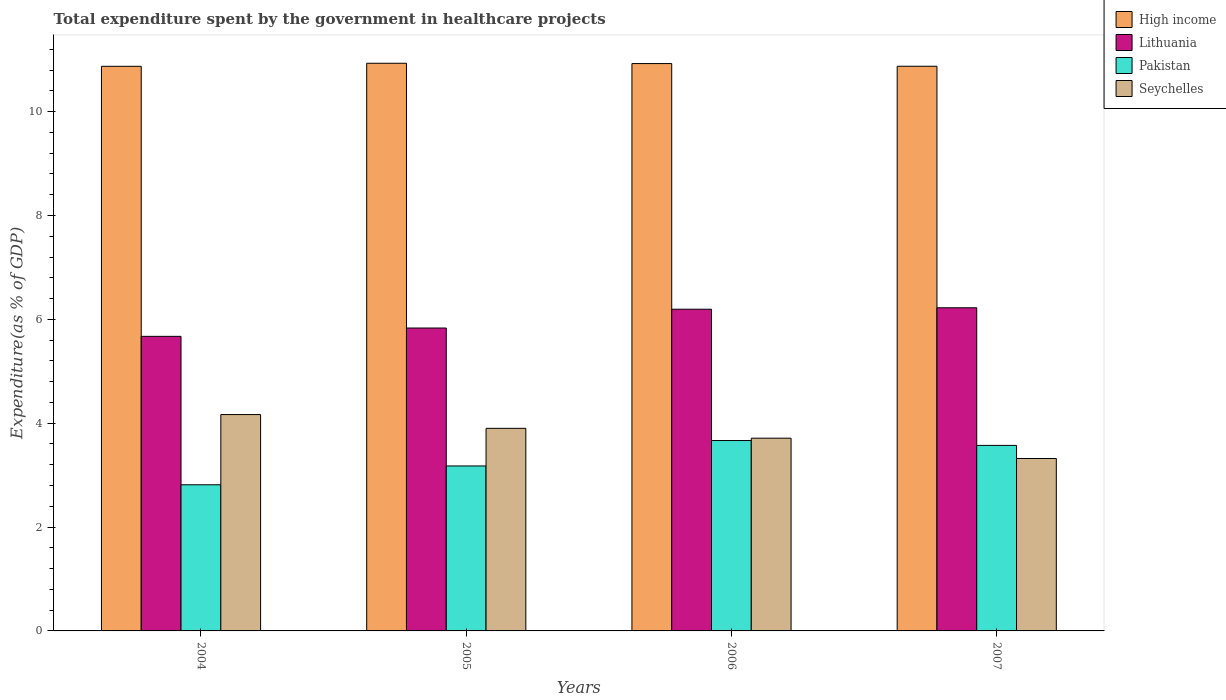How many different coloured bars are there?
Provide a short and direct response. 4. How many groups of bars are there?
Make the answer very short. 4. What is the label of the 4th group of bars from the left?
Ensure brevity in your answer.  2007. In how many cases, is the number of bars for a given year not equal to the number of legend labels?
Your answer should be compact. 0. What is the total expenditure spent by the government in healthcare projects in High income in 2005?
Your answer should be very brief. 10.93. Across all years, what is the maximum total expenditure spent by the government in healthcare projects in Pakistan?
Your response must be concise. 3.67. Across all years, what is the minimum total expenditure spent by the government in healthcare projects in High income?
Offer a terse response. 10.87. In which year was the total expenditure spent by the government in healthcare projects in Seychelles minimum?
Provide a short and direct response. 2007. What is the total total expenditure spent by the government in healthcare projects in Pakistan in the graph?
Keep it short and to the point. 13.23. What is the difference between the total expenditure spent by the government in healthcare projects in High income in 2004 and that in 2006?
Provide a short and direct response. -0.05. What is the difference between the total expenditure spent by the government in healthcare projects in Pakistan in 2007 and the total expenditure spent by the government in healthcare projects in Lithuania in 2004?
Offer a very short reply. -2.1. What is the average total expenditure spent by the government in healthcare projects in Seychelles per year?
Your response must be concise. 3.77. In the year 2004, what is the difference between the total expenditure spent by the government in healthcare projects in High income and total expenditure spent by the government in healthcare projects in Pakistan?
Ensure brevity in your answer.  8.06. What is the ratio of the total expenditure spent by the government in healthcare projects in High income in 2004 to that in 2006?
Provide a short and direct response. 1. Is the difference between the total expenditure spent by the government in healthcare projects in High income in 2005 and 2007 greater than the difference between the total expenditure spent by the government in healthcare projects in Pakistan in 2005 and 2007?
Provide a short and direct response. Yes. What is the difference between the highest and the second highest total expenditure spent by the government in healthcare projects in High income?
Give a very brief answer. 0.01. What is the difference between the highest and the lowest total expenditure spent by the government in healthcare projects in Pakistan?
Your response must be concise. 0.85. What does the 4th bar from the left in 2006 represents?
Offer a very short reply. Seychelles. What does the 4th bar from the right in 2004 represents?
Provide a succinct answer. High income. How many bars are there?
Offer a terse response. 16. How many years are there in the graph?
Provide a short and direct response. 4. What is the difference between two consecutive major ticks on the Y-axis?
Your response must be concise. 2. Are the values on the major ticks of Y-axis written in scientific E-notation?
Offer a terse response. No. Does the graph contain grids?
Your answer should be compact. No. Where does the legend appear in the graph?
Make the answer very short. Top right. How are the legend labels stacked?
Your answer should be compact. Vertical. What is the title of the graph?
Provide a succinct answer. Total expenditure spent by the government in healthcare projects. Does "Fragile and conflict affected situations" appear as one of the legend labels in the graph?
Your answer should be very brief. No. What is the label or title of the Y-axis?
Your answer should be very brief. Expenditure(as % of GDP). What is the Expenditure(as % of GDP) of High income in 2004?
Keep it short and to the point. 10.87. What is the Expenditure(as % of GDP) of Lithuania in 2004?
Offer a terse response. 5.67. What is the Expenditure(as % of GDP) in Pakistan in 2004?
Provide a succinct answer. 2.81. What is the Expenditure(as % of GDP) in Seychelles in 2004?
Give a very brief answer. 4.17. What is the Expenditure(as % of GDP) of High income in 2005?
Your response must be concise. 10.93. What is the Expenditure(as % of GDP) in Lithuania in 2005?
Offer a very short reply. 5.83. What is the Expenditure(as % of GDP) in Pakistan in 2005?
Offer a terse response. 3.18. What is the Expenditure(as % of GDP) in Seychelles in 2005?
Your response must be concise. 3.9. What is the Expenditure(as % of GDP) in High income in 2006?
Provide a short and direct response. 10.93. What is the Expenditure(as % of GDP) in Lithuania in 2006?
Keep it short and to the point. 6.2. What is the Expenditure(as % of GDP) in Pakistan in 2006?
Your answer should be very brief. 3.67. What is the Expenditure(as % of GDP) in Seychelles in 2006?
Make the answer very short. 3.71. What is the Expenditure(as % of GDP) in High income in 2007?
Your answer should be very brief. 10.87. What is the Expenditure(as % of GDP) of Lithuania in 2007?
Provide a succinct answer. 6.22. What is the Expenditure(as % of GDP) of Pakistan in 2007?
Keep it short and to the point. 3.57. What is the Expenditure(as % of GDP) in Seychelles in 2007?
Provide a succinct answer. 3.32. Across all years, what is the maximum Expenditure(as % of GDP) of High income?
Your answer should be compact. 10.93. Across all years, what is the maximum Expenditure(as % of GDP) in Lithuania?
Offer a very short reply. 6.22. Across all years, what is the maximum Expenditure(as % of GDP) of Pakistan?
Offer a terse response. 3.67. Across all years, what is the maximum Expenditure(as % of GDP) in Seychelles?
Ensure brevity in your answer.  4.17. Across all years, what is the minimum Expenditure(as % of GDP) of High income?
Keep it short and to the point. 10.87. Across all years, what is the minimum Expenditure(as % of GDP) of Lithuania?
Your response must be concise. 5.67. Across all years, what is the minimum Expenditure(as % of GDP) in Pakistan?
Keep it short and to the point. 2.81. Across all years, what is the minimum Expenditure(as % of GDP) in Seychelles?
Ensure brevity in your answer.  3.32. What is the total Expenditure(as % of GDP) in High income in the graph?
Keep it short and to the point. 43.61. What is the total Expenditure(as % of GDP) in Lithuania in the graph?
Offer a very short reply. 23.92. What is the total Expenditure(as % of GDP) of Pakistan in the graph?
Offer a terse response. 13.23. What is the total Expenditure(as % of GDP) of Seychelles in the graph?
Provide a short and direct response. 15.1. What is the difference between the Expenditure(as % of GDP) in High income in 2004 and that in 2005?
Give a very brief answer. -0.06. What is the difference between the Expenditure(as % of GDP) in Lithuania in 2004 and that in 2005?
Your response must be concise. -0.16. What is the difference between the Expenditure(as % of GDP) in Pakistan in 2004 and that in 2005?
Your response must be concise. -0.36. What is the difference between the Expenditure(as % of GDP) of Seychelles in 2004 and that in 2005?
Your answer should be very brief. 0.27. What is the difference between the Expenditure(as % of GDP) in High income in 2004 and that in 2006?
Keep it short and to the point. -0.05. What is the difference between the Expenditure(as % of GDP) of Lithuania in 2004 and that in 2006?
Make the answer very short. -0.52. What is the difference between the Expenditure(as % of GDP) in Pakistan in 2004 and that in 2006?
Keep it short and to the point. -0.85. What is the difference between the Expenditure(as % of GDP) in Seychelles in 2004 and that in 2006?
Your answer should be very brief. 0.45. What is the difference between the Expenditure(as % of GDP) in High income in 2004 and that in 2007?
Keep it short and to the point. -0. What is the difference between the Expenditure(as % of GDP) of Lithuania in 2004 and that in 2007?
Provide a short and direct response. -0.55. What is the difference between the Expenditure(as % of GDP) in Pakistan in 2004 and that in 2007?
Your answer should be very brief. -0.76. What is the difference between the Expenditure(as % of GDP) in Seychelles in 2004 and that in 2007?
Make the answer very short. 0.85. What is the difference between the Expenditure(as % of GDP) in High income in 2005 and that in 2006?
Keep it short and to the point. 0.01. What is the difference between the Expenditure(as % of GDP) of Lithuania in 2005 and that in 2006?
Your response must be concise. -0.36. What is the difference between the Expenditure(as % of GDP) in Pakistan in 2005 and that in 2006?
Your answer should be very brief. -0.49. What is the difference between the Expenditure(as % of GDP) of Seychelles in 2005 and that in 2006?
Your answer should be compact. 0.19. What is the difference between the Expenditure(as % of GDP) of High income in 2005 and that in 2007?
Keep it short and to the point. 0.06. What is the difference between the Expenditure(as % of GDP) of Lithuania in 2005 and that in 2007?
Make the answer very short. -0.39. What is the difference between the Expenditure(as % of GDP) of Pakistan in 2005 and that in 2007?
Your answer should be compact. -0.4. What is the difference between the Expenditure(as % of GDP) of Seychelles in 2005 and that in 2007?
Your answer should be compact. 0.58. What is the difference between the Expenditure(as % of GDP) of High income in 2006 and that in 2007?
Offer a terse response. 0.05. What is the difference between the Expenditure(as % of GDP) of Lithuania in 2006 and that in 2007?
Offer a very short reply. -0.03. What is the difference between the Expenditure(as % of GDP) of Pakistan in 2006 and that in 2007?
Your answer should be very brief. 0.09. What is the difference between the Expenditure(as % of GDP) of Seychelles in 2006 and that in 2007?
Offer a very short reply. 0.39. What is the difference between the Expenditure(as % of GDP) in High income in 2004 and the Expenditure(as % of GDP) in Lithuania in 2005?
Make the answer very short. 5.04. What is the difference between the Expenditure(as % of GDP) in High income in 2004 and the Expenditure(as % of GDP) in Pakistan in 2005?
Provide a short and direct response. 7.7. What is the difference between the Expenditure(as % of GDP) in High income in 2004 and the Expenditure(as % of GDP) in Seychelles in 2005?
Your answer should be very brief. 6.97. What is the difference between the Expenditure(as % of GDP) of Lithuania in 2004 and the Expenditure(as % of GDP) of Pakistan in 2005?
Give a very brief answer. 2.5. What is the difference between the Expenditure(as % of GDP) in Lithuania in 2004 and the Expenditure(as % of GDP) in Seychelles in 2005?
Make the answer very short. 1.77. What is the difference between the Expenditure(as % of GDP) in Pakistan in 2004 and the Expenditure(as % of GDP) in Seychelles in 2005?
Your answer should be very brief. -1.09. What is the difference between the Expenditure(as % of GDP) in High income in 2004 and the Expenditure(as % of GDP) in Lithuania in 2006?
Keep it short and to the point. 4.68. What is the difference between the Expenditure(as % of GDP) in High income in 2004 and the Expenditure(as % of GDP) in Pakistan in 2006?
Make the answer very short. 7.21. What is the difference between the Expenditure(as % of GDP) of High income in 2004 and the Expenditure(as % of GDP) of Seychelles in 2006?
Your answer should be compact. 7.16. What is the difference between the Expenditure(as % of GDP) in Lithuania in 2004 and the Expenditure(as % of GDP) in Pakistan in 2006?
Offer a terse response. 2.01. What is the difference between the Expenditure(as % of GDP) in Lithuania in 2004 and the Expenditure(as % of GDP) in Seychelles in 2006?
Offer a terse response. 1.96. What is the difference between the Expenditure(as % of GDP) in Pakistan in 2004 and the Expenditure(as % of GDP) in Seychelles in 2006?
Make the answer very short. -0.9. What is the difference between the Expenditure(as % of GDP) in High income in 2004 and the Expenditure(as % of GDP) in Lithuania in 2007?
Provide a succinct answer. 4.65. What is the difference between the Expenditure(as % of GDP) of High income in 2004 and the Expenditure(as % of GDP) of Pakistan in 2007?
Keep it short and to the point. 7.3. What is the difference between the Expenditure(as % of GDP) of High income in 2004 and the Expenditure(as % of GDP) of Seychelles in 2007?
Provide a short and direct response. 7.55. What is the difference between the Expenditure(as % of GDP) in Lithuania in 2004 and the Expenditure(as % of GDP) in Pakistan in 2007?
Ensure brevity in your answer.  2.1. What is the difference between the Expenditure(as % of GDP) of Lithuania in 2004 and the Expenditure(as % of GDP) of Seychelles in 2007?
Keep it short and to the point. 2.35. What is the difference between the Expenditure(as % of GDP) in Pakistan in 2004 and the Expenditure(as % of GDP) in Seychelles in 2007?
Make the answer very short. -0.51. What is the difference between the Expenditure(as % of GDP) of High income in 2005 and the Expenditure(as % of GDP) of Lithuania in 2006?
Your answer should be compact. 4.74. What is the difference between the Expenditure(as % of GDP) in High income in 2005 and the Expenditure(as % of GDP) in Pakistan in 2006?
Provide a short and direct response. 7.27. What is the difference between the Expenditure(as % of GDP) in High income in 2005 and the Expenditure(as % of GDP) in Seychelles in 2006?
Your response must be concise. 7.22. What is the difference between the Expenditure(as % of GDP) in Lithuania in 2005 and the Expenditure(as % of GDP) in Pakistan in 2006?
Your answer should be compact. 2.17. What is the difference between the Expenditure(as % of GDP) of Lithuania in 2005 and the Expenditure(as % of GDP) of Seychelles in 2006?
Your answer should be very brief. 2.12. What is the difference between the Expenditure(as % of GDP) in Pakistan in 2005 and the Expenditure(as % of GDP) in Seychelles in 2006?
Your answer should be compact. -0.53. What is the difference between the Expenditure(as % of GDP) of High income in 2005 and the Expenditure(as % of GDP) of Lithuania in 2007?
Provide a short and direct response. 4.71. What is the difference between the Expenditure(as % of GDP) of High income in 2005 and the Expenditure(as % of GDP) of Pakistan in 2007?
Provide a succinct answer. 7.36. What is the difference between the Expenditure(as % of GDP) in High income in 2005 and the Expenditure(as % of GDP) in Seychelles in 2007?
Provide a short and direct response. 7.61. What is the difference between the Expenditure(as % of GDP) of Lithuania in 2005 and the Expenditure(as % of GDP) of Pakistan in 2007?
Make the answer very short. 2.26. What is the difference between the Expenditure(as % of GDP) of Lithuania in 2005 and the Expenditure(as % of GDP) of Seychelles in 2007?
Your answer should be compact. 2.51. What is the difference between the Expenditure(as % of GDP) of Pakistan in 2005 and the Expenditure(as % of GDP) of Seychelles in 2007?
Your response must be concise. -0.14. What is the difference between the Expenditure(as % of GDP) of High income in 2006 and the Expenditure(as % of GDP) of Lithuania in 2007?
Offer a terse response. 4.7. What is the difference between the Expenditure(as % of GDP) of High income in 2006 and the Expenditure(as % of GDP) of Pakistan in 2007?
Keep it short and to the point. 7.35. What is the difference between the Expenditure(as % of GDP) in High income in 2006 and the Expenditure(as % of GDP) in Seychelles in 2007?
Your answer should be compact. 7.61. What is the difference between the Expenditure(as % of GDP) of Lithuania in 2006 and the Expenditure(as % of GDP) of Pakistan in 2007?
Make the answer very short. 2.62. What is the difference between the Expenditure(as % of GDP) in Lithuania in 2006 and the Expenditure(as % of GDP) in Seychelles in 2007?
Give a very brief answer. 2.87. What is the difference between the Expenditure(as % of GDP) in Pakistan in 2006 and the Expenditure(as % of GDP) in Seychelles in 2007?
Ensure brevity in your answer.  0.35. What is the average Expenditure(as % of GDP) in High income per year?
Your answer should be compact. 10.9. What is the average Expenditure(as % of GDP) of Lithuania per year?
Your response must be concise. 5.98. What is the average Expenditure(as % of GDP) of Pakistan per year?
Offer a terse response. 3.31. What is the average Expenditure(as % of GDP) of Seychelles per year?
Your response must be concise. 3.77. In the year 2004, what is the difference between the Expenditure(as % of GDP) of High income and Expenditure(as % of GDP) of Lithuania?
Ensure brevity in your answer.  5.2. In the year 2004, what is the difference between the Expenditure(as % of GDP) in High income and Expenditure(as % of GDP) in Pakistan?
Offer a very short reply. 8.06. In the year 2004, what is the difference between the Expenditure(as % of GDP) in High income and Expenditure(as % of GDP) in Seychelles?
Make the answer very short. 6.71. In the year 2004, what is the difference between the Expenditure(as % of GDP) in Lithuania and Expenditure(as % of GDP) in Pakistan?
Keep it short and to the point. 2.86. In the year 2004, what is the difference between the Expenditure(as % of GDP) in Lithuania and Expenditure(as % of GDP) in Seychelles?
Provide a short and direct response. 1.51. In the year 2004, what is the difference between the Expenditure(as % of GDP) of Pakistan and Expenditure(as % of GDP) of Seychelles?
Your answer should be compact. -1.35. In the year 2005, what is the difference between the Expenditure(as % of GDP) of High income and Expenditure(as % of GDP) of Lithuania?
Offer a terse response. 5.1. In the year 2005, what is the difference between the Expenditure(as % of GDP) in High income and Expenditure(as % of GDP) in Pakistan?
Make the answer very short. 7.76. In the year 2005, what is the difference between the Expenditure(as % of GDP) in High income and Expenditure(as % of GDP) in Seychelles?
Give a very brief answer. 7.03. In the year 2005, what is the difference between the Expenditure(as % of GDP) of Lithuania and Expenditure(as % of GDP) of Pakistan?
Offer a terse response. 2.66. In the year 2005, what is the difference between the Expenditure(as % of GDP) in Lithuania and Expenditure(as % of GDP) in Seychelles?
Keep it short and to the point. 1.93. In the year 2005, what is the difference between the Expenditure(as % of GDP) of Pakistan and Expenditure(as % of GDP) of Seychelles?
Offer a terse response. -0.72. In the year 2006, what is the difference between the Expenditure(as % of GDP) of High income and Expenditure(as % of GDP) of Lithuania?
Keep it short and to the point. 4.73. In the year 2006, what is the difference between the Expenditure(as % of GDP) in High income and Expenditure(as % of GDP) in Pakistan?
Offer a very short reply. 7.26. In the year 2006, what is the difference between the Expenditure(as % of GDP) of High income and Expenditure(as % of GDP) of Seychelles?
Your response must be concise. 7.21. In the year 2006, what is the difference between the Expenditure(as % of GDP) in Lithuania and Expenditure(as % of GDP) in Pakistan?
Keep it short and to the point. 2.53. In the year 2006, what is the difference between the Expenditure(as % of GDP) of Lithuania and Expenditure(as % of GDP) of Seychelles?
Give a very brief answer. 2.48. In the year 2006, what is the difference between the Expenditure(as % of GDP) of Pakistan and Expenditure(as % of GDP) of Seychelles?
Make the answer very short. -0.05. In the year 2007, what is the difference between the Expenditure(as % of GDP) in High income and Expenditure(as % of GDP) in Lithuania?
Your answer should be very brief. 4.65. In the year 2007, what is the difference between the Expenditure(as % of GDP) of High income and Expenditure(as % of GDP) of Pakistan?
Your response must be concise. 7.3. In the year 2007, what is the difference between the Expenditure(as % of GDP) in High income and Expenditure(as % of GDP) in Seychelles?
Give a very brief answer. 7.55. In the year 2007, what is the difference between the Expenditure(as % of GDP) in Lithuania and Expenditure(as % of GDP) in Pakistan?
Make the answer very short. 2.65. In the year 2007, what is the difference between the Expenditure(as % of GDP) of Lithuania and Expenditure(as % of GDP) of Seychelles?
Offer a terse response. 2.9. In the year 2007, what is the difference between the Expenditure(as % of GDP) in Pakistan and Expenditure(as % of GDP) in Seychelles?
Ensure brevity in your answer.  0.25. What is the ratio of the Expenditure(as % of GDP) in High income in 2004 to that in 2005?
Make the answer very short. 0.99. What is the ratio of the Expenditure(as % of GDP) in Lithuania in 2004 to that in 2005?
Your answer should be very brief. 0.97. What is the ratio of the Expenditure(as % of GDP) in Pakistan in 2004 to that in 2005?
Offer a very short reply. 0.89. What is the ratio of the Expenditure(as % of GDP) of Seychelles in 2004 to that in 2005?
Keep it short and to the point. 1.07. What is the ratio of the Expenditure(as % of GDP) in High income in 2004 to that in 2006?
Make the answer very short. 1. What is the ratio of the Expenditure(as % of GDP) of Lithuania in 2004 to that in 2006?
Provide a short and direct response. 0.92. What is the ratio of the Expenditure(as % of GDP) in Pakistan in 2004 to that in 2006?
Make the answer very short. 0.77. What is the ratio of the Expenditure(as % of GDP) of Seychelles in 2004 to that in 2006?
Your answer should be compact. 1.12. What is the ratio of the Expenditure(as % of GDP) in Lithuania in 2004 to that in 2007?
Provide a short and direct response. 0.91. What is the ratio of the Expenditure(as % of GDP) of Pakistan in 2004 to that in 2007?
Give a very brief answer. 0.79. What is the ratio of the Expenditure(as % of GDP) in Seychelles in 2004 to that in 2007?
Offer a terse response. 1.25. What is the ratio of the Expenditure(as % of GDP) of High income in 2005 to that in 2006?
Your response must be concise. 1. What is the ratio of the Expenditure(as % of GDP) of Lithuania in 2005 to that in 2006?
Make the answer very short. 0.94. What is the ratio of the Expenditure(as % of GDP) of Pakistan in 2005 to that in 2006?
Your response must be concise. 0.87. What is the ratio of the Expenditure(as % of GDP) of Seychelles in 2005 to that in 2006?
Your answer should be very brief. 1.05. What is the ratio of the Expenditure(as % of GDP) in High income in 2005 to that in 2007?
Provide a short and direct response. 1.01. What is the ratio of the Expenditure(as % of GDP) in Lithuania in 2005 to that in 2007?
Keep it short and to the point. 0.94. What is the ratio of the Expenditure(as % of GDP) of Pakistan in 2005 to that in 2007?
Give a very brief answer. 0.89. What is the ratio of the Expenditure(as % of GDP) of Seychelles in 2005 to that in 2007?
Ensure brevity in your answer.  1.18. What is the ratio of the Expenditure(as % of GDP) in High income in 2006 to that in 2007?
Make the answer very short. 1. What is the ratio of the Expenditure(as % of GDP) of Lithuania in 2006 to that in 2007?
Ensure brevity in your answer.  1. What is the ratio of the Expenditure(as % of GDP) in Pakistan in 2006 to that in 2007?
Offer a very short reply. 1.03. What is the ratio of the Expenditure(as % of GDP) in Seychelles in 2006 to that in 2007?
Offer a terse response. 1.12. What is the difference between the highest and the second highest Expenditure(as % of GDP) of High income?
Give a very brief answer. 0.01. What is the difference between the highest and the second highest Expenditure(as % of GDP) of Lithuania?
Make the answer very short. 0.03. What is the difference between the highest and the second highest Expenditure(as % of GDP) in Pakistan?
Ensure brevity in your answer.  0.09. What is the difference between the highest and the second highest Expenditure(as % of GDP) of Seychelles?
Offer a terse response. 0.27. What is the difference between the highest and the lowest Expenditure(as % of GDP) in High income?
Your answer should be compact. 0.06. What is the difference between the highest and the lowest Expenditure(as % of GDP) in Lithuania?
Provide a short and direct response. 0.55. What is the difference between the highest and the lowest Expenditure(as % of GDP) in Pakistan?
Your answer should be compact. 0.85. What is the difference between the highest and the lowest Expenditure(as % of GDP) in Seychelles?
Give a very brief answer. 0.85. 